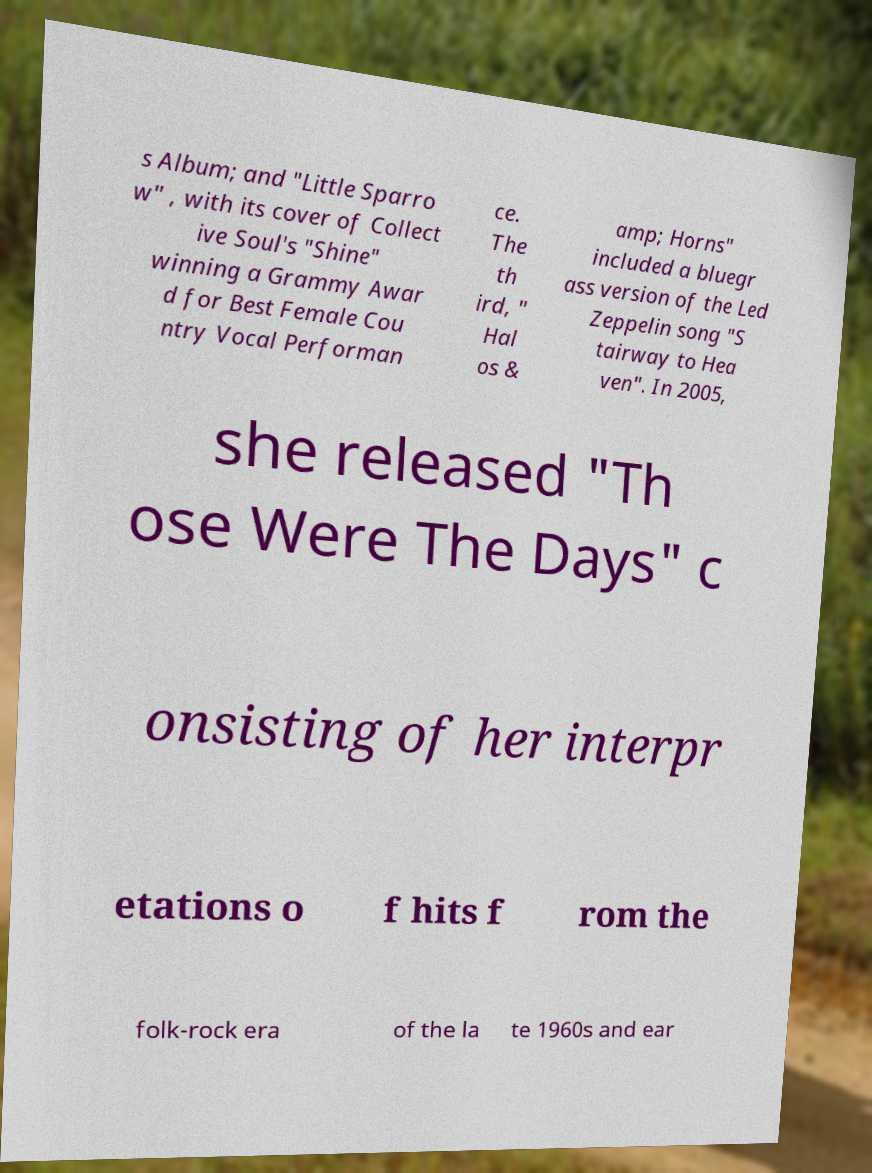For documentation purposes, I need the text within this image transcribed. Could you provide that? s Album; and "Little Sparro w" , with its cover of Collect ive Soul's "Shine" winning a Grammy Awar d for Best Female Cou ntry Vocal Performan ce. The th ird, " Hal os & amp; Horns" included a bluegr ass version of the Led Zeppelin song "S tairway to Hea ven". In 2005, she released "Th ose Were The Days" c onsisting of her interpr etations o f hits f rom the folk-rock era of the la te 1960s and ear 